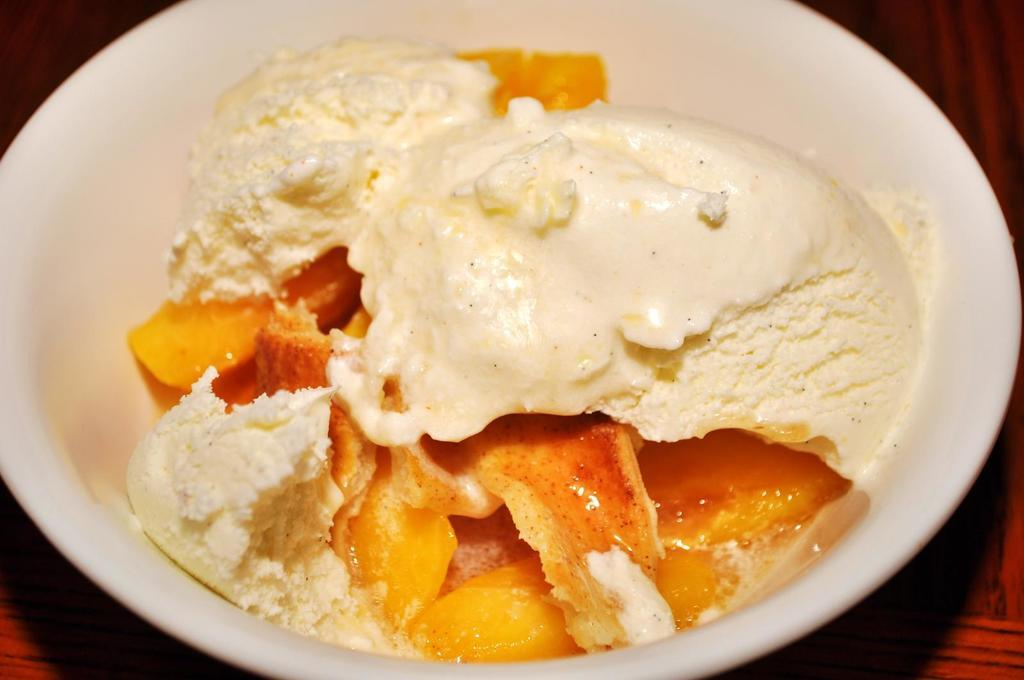What is in the bowl that is visible in the image? There is ice cream in the bowl in the image. What is the bowl placed on or near? There is a wooden platform at the bottom of the image. What type of garden can be seen in the background of the image? There is no garden visible in the image; it only shows a bowl of ice cream on a wooden platform. 